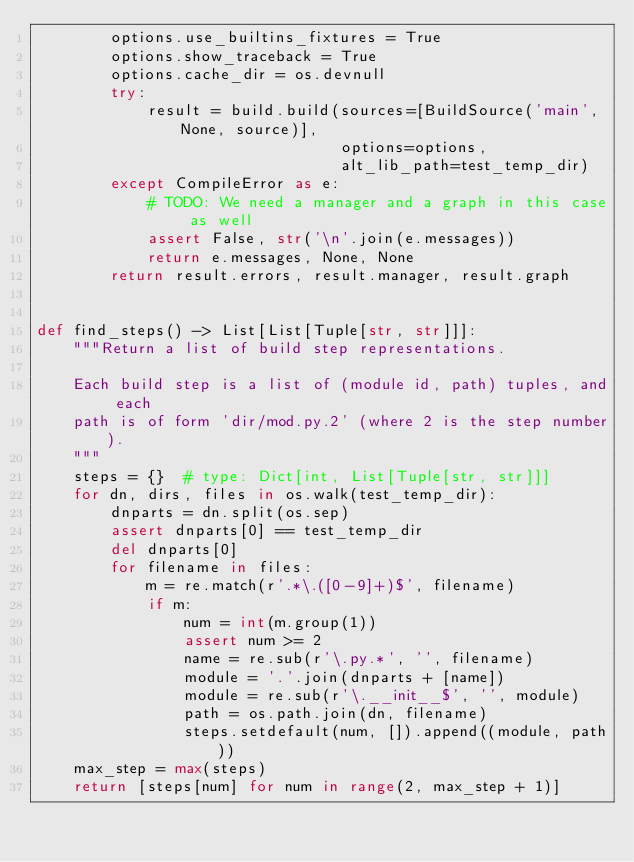<code> <loc_0><loc_0><loc_500><loc_500><_Python_>        options.use_builtins_fixtures = True
        options.show_traceback = True
        options.cache_dir = os.devnull
        try:
            result = build.build(sources=[BuildSource('main', None, source)],
                                 options=options,
                                 alt_lib_path=test_temp_dir)
        except CompileError as e:
            # TODO: We need a manager and a graph in this case as well
            assert False, str('\n'.join(e.messages))
            return e.messages, None, None
        return result.errors, result.manager, result.graph


def find_steps() -> List[List[Tuple[str, str]]]:
    """Return a list of build step representations.

    Each build step is a list of (module id, path) tuples, and each
    path is of form 'dir/mod.py.2' (where 2 is the step number).
    """
    steps = {}  # type: Dict[int, List[Tuple[str, str]]]
    for dn, dirs, files in os.walk(test_temp_dir):
        dnparts = dn.split(os.sep)
        assert dnparts[0] == test_temp_dir
        del dnparts[0]
        for filename in files:
            m = re.match(r'.*\.([0-9]+)$', filename)
            if m:
                num = int(m.group(1))
                assert num >= 2
                name = re.sub(r'\.py.*', '', filename)
                module = '.'.join(dnparts + [name])
                module = re.sub(r'\.__init__$', '', module)
                path = os.path.join(dn, filename)
                steps.setdefault(num, []).append((module, path))
    max_step = max(steps)
    return [steps[num] for num in range(2, max_step + 1)]
</code> 